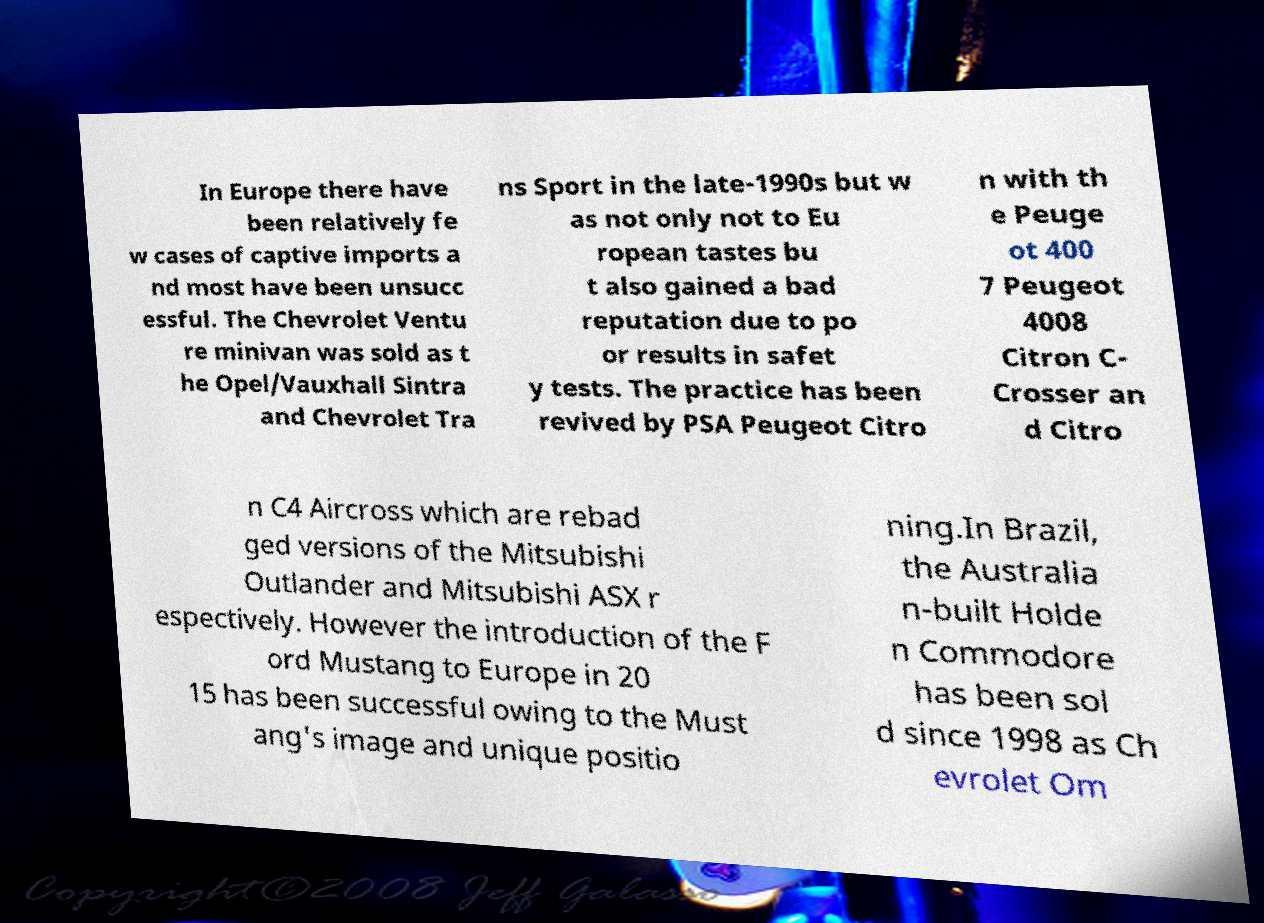Please identify and transcribe the text found in this image. In Europe there have been relatively fe w cases of captive imports a nd most have been unsucc essful. The Chevrolet Ventu re minivan was sold as t he Opel/Vauxhall Sintra and Chevrolet Tra ns Sport in the late-1990s but w as not only not to Eu ropean tastes bu t also gained a bad reputation due to po or results in safet y tests. The practice has been revived by PSA Peugeot Citro n with th e Peuge ot 400 7 Peugeot 4008 Citron C- Crosser an d Citro n C4 Aircross which are rebad ged versions of the Mitsubishi Outlander and Mitsubishi ASX r espectively. However the introduction of the F ord Mustang to Europe in 20 15 has been successful owing to the Must ang's image and unique positio ning.In Brazil, the Australia n-built Holde n Commodore has been sol d since 1998 as Ch evrolet Om 